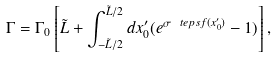Convert formula to latex. <formula><loc_0><loc_0><loc_500><loc_500>\Gamma = \Gamma _ { 0 } \left [ \tilde { L } + \int _ { - \tilde { L } / 2 } ^ { \tilde { L } / 2 } d x _ { 0 } ^ { \prime } ( e ^ { \sigma \ t e p s f ( x _ { 0 } ^ { \prime } ) } - 1 ) \right ] ,</formula> 